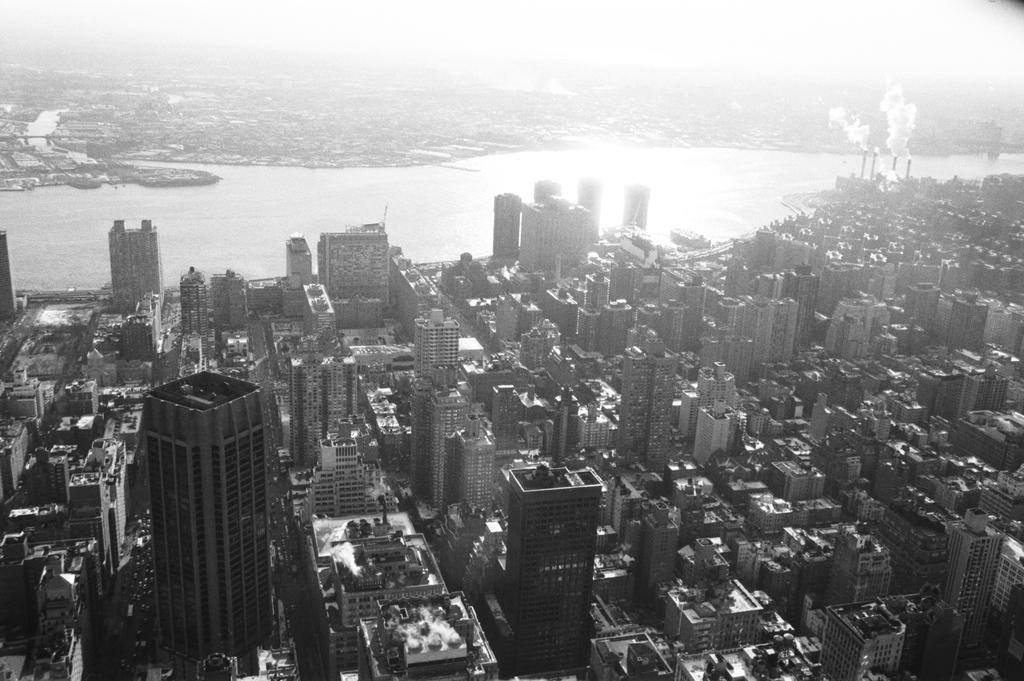Describe this image in one or two sentences. In this image in the middle there are buildings, water, smoke. 